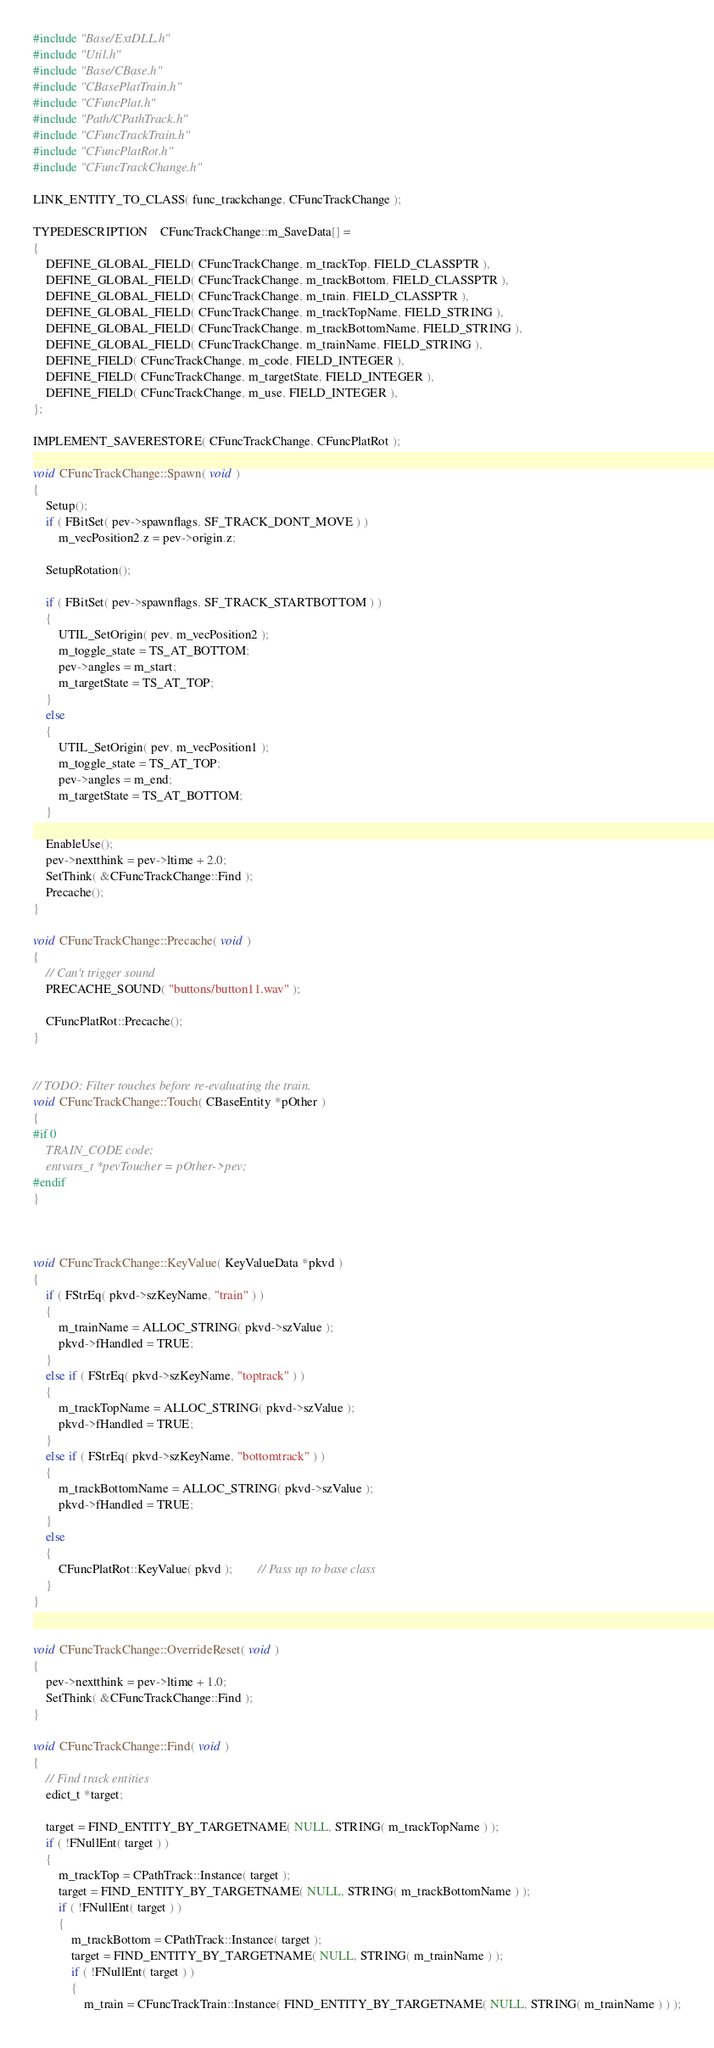Convert code to text. <code><loc_0><loc_0><loc_500><loc_500><_C++_>#include "Base/ExtDLL.h"
#include "Util.h"
#include "Base/CBase.h"
#include "CBasePlatTrain.h"
#include "CFuncPlat.h"
#include "Path/CPathTrack.h"
#include "CFuncTrackTrain.h"
#include "CFuncPlatRot.h"
#include "CFuncTrackChange.h"

LINK_ENTITY_TO_CLASS( func_trackchange, CFuncTrackChange );

TYPEDESCRIPTION	CFuncTrackChange::m_SaveData[] =
{
	DEFINE_GLOBAL_FIELD( CFuncTrackChange, m_trackTop, FIELD_CLASSPTR ),
	DEFINE_GLOBAL_FIELD( CFuncTrackChange, m_trackBottom, FIELD_CLASSPTR ),
	DEFINE_GLOBAL_FIELD( CFuncTrackChange, m_train, FIELD_CLASSPTR ),
	DEFINE_GLOBAL_FIELD( CFuncTrackChange, m_trackTopName, FIELD_STRING ),
	DEFINE_GLOBAL_FIELD( CFuncTrackChange, m_trackBottomName, FIELD_STRING ),
	DEFINE_GLOBAL_FIELD( CFuncTrackChange, m_trainName, FIELD_STRING ),
	DEFINE_FIELD( CFuncTrackChange, m_code, FIELD_INTEGER ),
	DEFINE_FIELD( CFuncTrackChange, m_targetState, FIELD_INTEGER ),
	DEFINE_FIELD( CFuncTrackChange, m_use, FIELD_INTEGER ),
};

IMPLEMENT_SAVERESTORE( CFuncTrackChange, CFuncPlatRot );

void CFuncTrackChange::Spawn( void )
{
	Setup();
	if ( FBitSet( pev->spawnflags, SF_TRACK_DONT_MOVE ) )
		m_vecPosition2.z = pev->origin.z;

	SetupRotation();

	if ( FBitSet( pev->spawnflags, SF_TRACK_STARTBOTTOM ) )
	{
		UTIL_SetOrigin( pev, m_vecPosition2 );
		m_toggle_state = TS_AT_BOTTOM;
		pev->angles = m_start;
		m_targetState = TS_AT_TOP;
	}
	else
	{
		UTIL_SetOrigin( pev, m_vecPosition1 );
		m_toggle_state = TS_AT_TOP;
		pev->angles = m_end;
		m_targetState = TS_AT_BOTTOM;
	}

	EnableUse();
	pev->nextthink = pev->ltime + 2.0;
	SetThink( &CFuncTrackChange::Find );
	Precache();
}

void CFuncTrackChange::Precache( void )
{
	// Can't trigger sound
	PRECACHE_SOUND( "buttons/button11.wav" );

	CFuncPlatRot::Precache();
}


// TODO: Filter touches before re-evaluating the train.
void CFuncTrackChange::Touch( CBaseEntity *pOther )
{
#if 0
	TRAIN_CODE code;
	entvars_t *pevToucher = pOther->pev;
#endif
}



void CFuncTrackChange::KeyValue( KeyValueData *pkvd )
{
	if ( FStrEq( pkvd->szKeyName, "train" ) )
	{
		m_trainName = ALLOC_STRING( pkvd->szValue );
		pkvd->fHandled = TRUE;
	}
	else if ( FStrEq( pkvd->szKeyName, "toptrack" ) )
	{
		m_trackTopName = ALLOC_STRING( pkvd->szValue );
		pkvd->fHandled = TRUE;
	}
	else if ( FStrEq( pkvd->szKeyName, "bottomtrack" ) )
	{
		m_trackBottomName = ALLOC_STRING( pkvd->szValue );
		pkvd->fHandled = TRUE;
	}
	else
	{
		CFuncPlatRot::KeyValue( pkvd );		// Pass up to base class
	}
}


void CFuncTrackChange::OverrideReset( void )
{
	pev->nextthink = pev->ltime + 1.0;
	SetThink( &CFuncTrackChange::Find );
}

void CFuncTrackChange::Find( void )
{
	// Find track entities
	edict_t *target;

	target = FIND_ENTITY_BY_TARGETNAME( NULL, STRING( m_trackTopName ) );
	if ( !FNullEnt( target ) )
	{
		m_trackTop = CPathTrack::Instance( target );
		target = FIND_ENTITY_BY_TARGETNAME( NULL, STRING( m_trackBottomName ) );
		if ( !FNullEnt( target ) )
		{
			m_trackBottom = CPathTrack::Instance( target );
			target = FIND_ENTITY_BY_TARGETNAME( NULL, STRING( m_trainName ) );
			if ( !FNullEnt( target ) )
			{
				m_train = CFuncTrackTrain::Instance( FIND_ENTITY_BY_TARGETNAME( NULL, STRING( m_trainName ) ) );</code> 